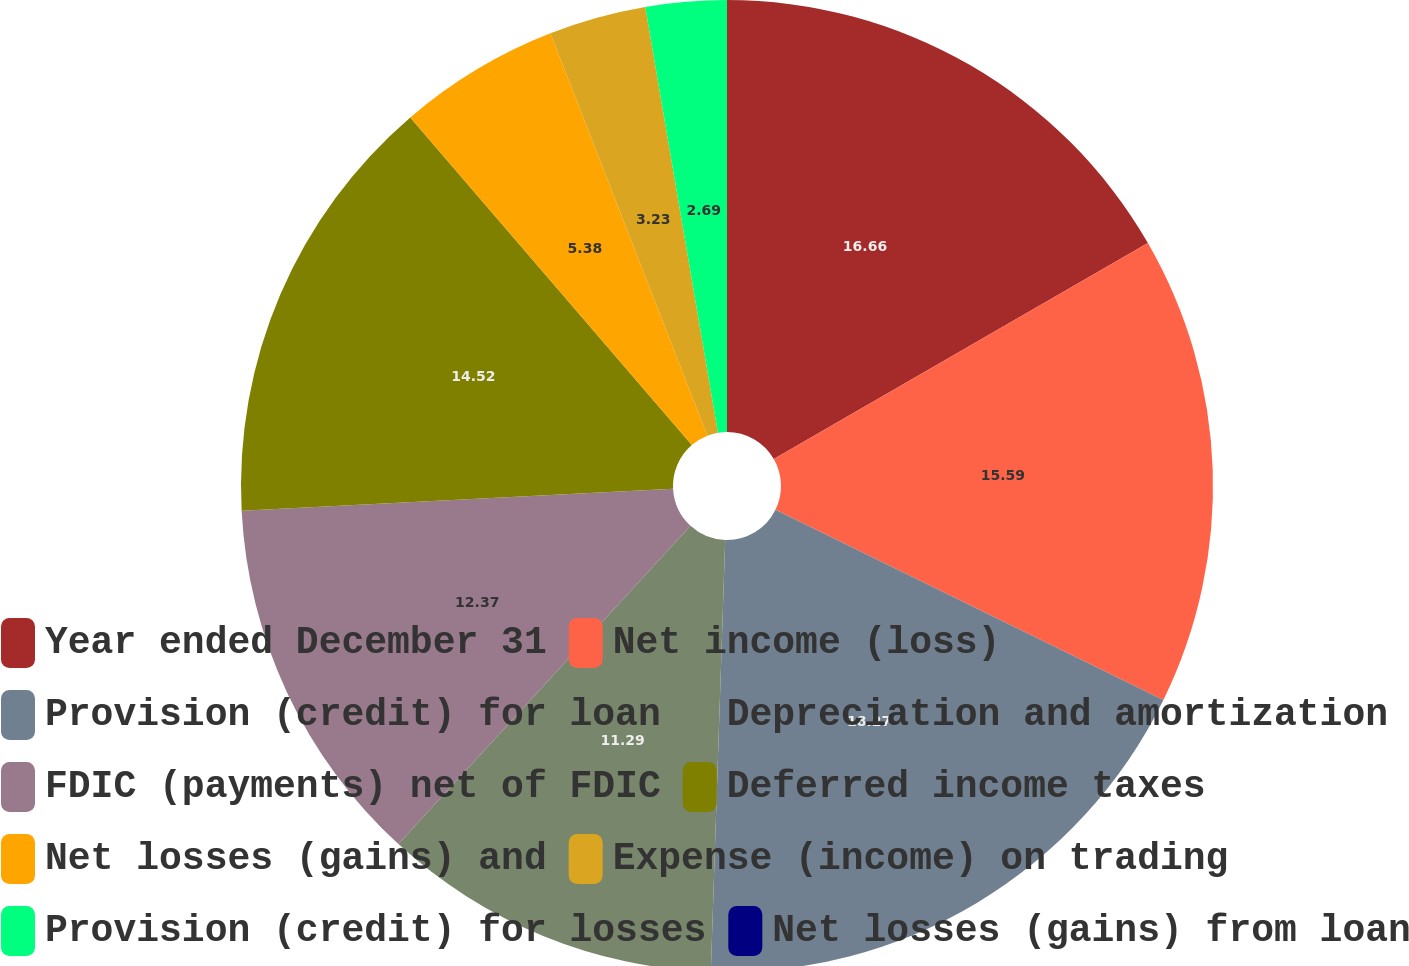Convert chart to OTSL. <chart><loc_0><loc_0><loc_500><loc_500><pie_chart><fcel>Year ended December 31<fcel>Net income (loss)<fcel>Provision (credit) for loan<fcel>Depreciation and amortization<fcel>FDIC (payments) net of FDIC<fcel>Deferred income taxes<fcel>Net losses (gains) and<fcel>Expense (income) on trading<fcel>Provision (credit) for losses<fcel>Net losses (gains) from loan<nl><fcel>16.67%<fcel>15.59%<fcel>18.28%<fcel>11.29%<fcel>12.37%<fcel>14.52%<fcel>5.38%<fcel>3.23%<fcel>2.69%<fcel>0.0%<nl></chart> 